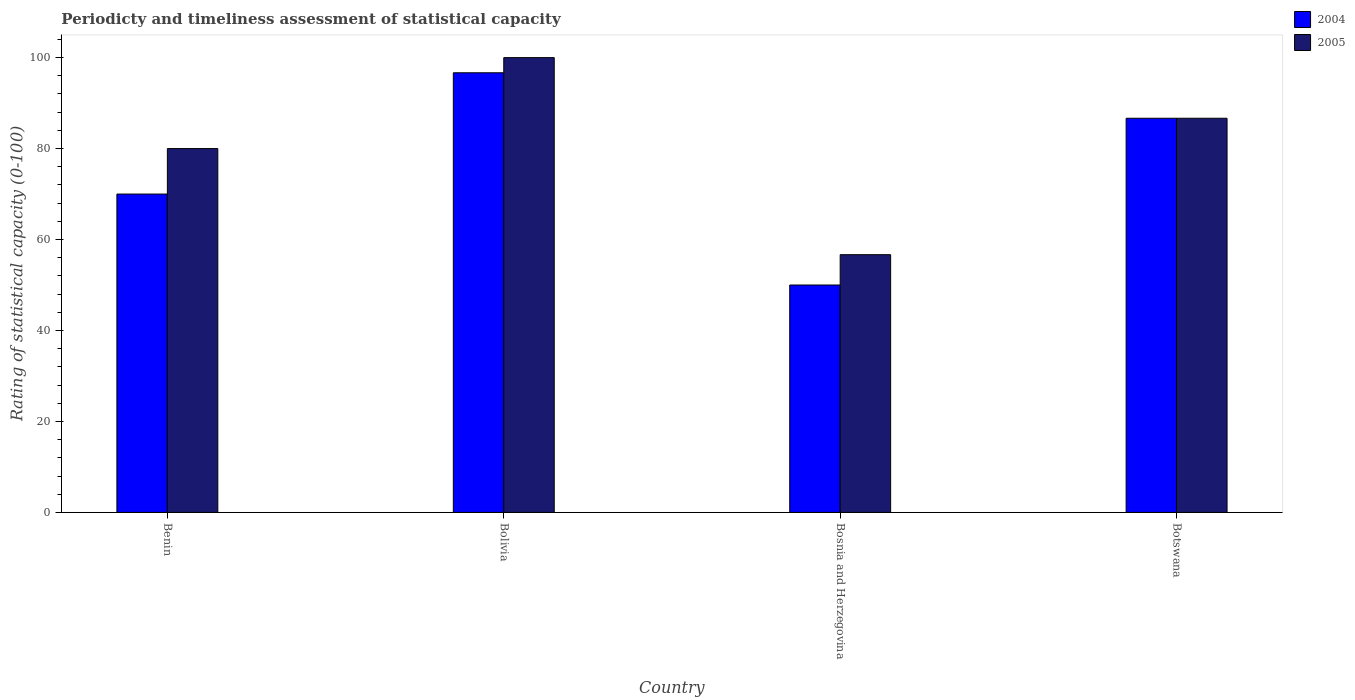How many different coloured bars are there?
Keep it short and to the point. 2. Are the number of bars per tick equal to the number of legend labels?
Provide a short and direct response. Yes. Are the number of bars on each tick of the X-axis equal?
Provide a short and direct response. Yes. What is the label of the 1st group of bars from the left?
Your response must be concise. Benin. In how many cases, is the number of bars for a given country not equal to the number of legend labels?
Your answer should be compact. 0. Across all countries, what is the maximum rating of statistical capacity in 2004?
Provide a succinct answer. 96.67. Across all countries, what is the minimum rating of statistical capacity in 2005?
Give a very brief answer. 56.67. In which country was the rating of statistical capacity in 2005 minimum?
Offer a terse response. Bosnia and Herzegovina. What is the total rating of statistical capacity in 2004 in the graph?
Offer a very short reply. 303.33. What is the difference between the rating of statistical capacity in 2005 in Bosnia and Herzegovina and that in Botswana?
Provide a short and direct response. -30. What is the difference between the rating of statistical capacity in 2004 in Bosnia and Herzegovina and the rating of statistical capacity in 2005 in Bolivia?
Your answer should be very brief. -50. What is the average rating of statistical capacity in 2004 per country?
Your answer should be compact. 75.83. What is the difference between the rating of statistical capacity of/in 2005 and rating of statistical capacity of/in 2004 in Botswana?
Your response must be concise. 0. In how many countries, is the rating of statistical capacity in 2005 greater than 68?
Give a very brief answer. 3. What is the ratio of the rating of statistical capacity in 2005 in Bolivia to that in Botswana?
Your answer should be very brief. 1.15. Is the rating of statistical capacity in 2005 in Benin less than that in Bosnia and Herzegovina?
Provide a short and direct response. No. Is the difference between the rating of statistical capacity in 2005 in Bolivia and Bosnia and Herzegovina greater than the difference between the rating of statistical capacity in 2004 in Bolivia and Bosnia and Herzegovina?
Offer a terse response. No. What is the difference between the highest and the second highest rating of statistical capacity in 2004?
Your response must be concise. 26.67. What is the difference between the highest and the lowest rating of statistical capacity in 2005?
Offer a very short reply. 43.33. In how many countries, is the rating of statistical capacity in 2004 greater than the average rating of statistical capacity in 2004 taken over all countries?
Offer a terse response. 2. What does the 1st bar from the left in Bolivia represents?
Provide a short and direct response. 2004. What does the 1st bar from the right in Bolivia represents?
Provide a short and direct response. 2005. Does the graph contain any zero values?
Your answer should be compact. No. Does the graph contain grids?
Offer a terse response. No. What is the title of the graph?
Your answer should be very brief. Periodicty and timeliness assessment of statistical capacity. What is the label or title of the X-axis?
Keep it short and to the point. Country. What is the label or title of the Y-axis?
Provide a short and direct response. Rating of statistical capacity (0-100). What is the Rating of statistical capacity (0-100) of 2004 in Bolivia?
Provide a succinct answer. 96.67. What is the Rating of statistical capacity (0-100) of 2004 in Bosnia and Herzegovina?
Give a very brief answer. 50. What is the Rating of statistical capacity (0-100) in 2005 in Bosnia and Herzegovina?
Ensure brevity in your answer.  56.67. What is the Rating of statistical capacity (0-100) of 2004 in Botswana?
Your answer should be very brief. 86.67. What is the Rating of statistical capacity (0-100) of 2005 in Botswana?
Your response must be concise. 86.67. Across all countries, what is the maximum Rating of statistical capacity (0-100) in 2004?
Ensure brevity in your answer.  96.67. Across all countries, what is the maximum Rating of statistical capacity (0-100) of 2005?
Your response must be concise. 100. Across all countries, what is the minimum Rating of statistical capacity (0-100) of 2004?
Your answer should be very brief. 50. Across all countries, what is the minimum Rating of statistical capacity (0-100) in 2005?
Offer a terse response. 56.67. What is the total Rating of statistical capacity (0-100) of 2004 in the graph?
Provide a short and direct response. 303.33. What is the total Rating of statistical capacity (0-100) in 2005 in the graph?
Your answer should be very brief. 323.33. What is the difference between the Rating of statistical capacity (0-100) in 2004 in Benin and that in Bolivia?
Offer a terse response. -26.67. What is the difference between the Rating of statistical capacity (0-100) in 2005 in Benin and that in Bolivia?
Ensure brevity in your answer.  -20. What is the difference between the Rating of statistical capacity (0-100) in 2005 in Benin and that in Bosnia and Herzegovina?
Your answer should be very brief. 23.33. What is the difference between the Rating of statistical capacity (0-100) of 2004 in Benin and that in Botswana?
Ensure brevity in your answer.  -16.67. What is the difference between the Rating of statistical capacity (0-100) in 2005 in Benin and that in Botswana?
Give a very brief answer. -6.67. What is the difference between the Rating of statistical capacity (0-100) in 2004 in Bolivia and that in Bosnia and Herzegovina?
Ensure brevity in your answer.  46.67. What is the difference between the Rating of statistical capacity (0-100) of 2005 in Bolivia and that in Bosnia and Herzegovina?
Provide a short and direct response. 43.33. What is the difference between the Rating of statistical capacity (0-100) of 2004 in Bolivia and that in Botswana?
Offer a very short reply. 10. What is the difference between the Rating of statistical capacity (0-100) in 2005 in Bolivia and that in Botswana?
Your response must be concise. 13.33. What is the difference between the Rating of statistical capacity (0-100) of 2004 in Bosnia and Herzegovina and that in Botswana?
Give a very brief answer. -36.67. What is the difference between the Rating of statistical capacity (0-100) in 2005 in Bosnia and Herzegovina and that in Botswana?
Provide a succinct answer. -30. What is the difference between the Rating of statistical capacity (0-100) in 2004 in Benin and the Rating of statistical capacity (0-100) in 2005 in Bolivia?
Make the answer very short. -30. What is the difference between the Rating of statistical capacity (0-100) of 2004 in Benin and the Rating of statistical capacity (0-100) of 2005 in Bosnia and Herzegovina?
Your response must be concise. 13.33. What is the difference between the Rating of statistical capacity (0-100) of 2004 in Benin and the Rating of statistical capacity (0-100) of 2005 in Botswana?
Provide a succinct answer. -16.67. What is the difference between the Rating of statistical capacity (0-100) in 2004 in Bolivia and the Rating of statistical capacity (0-100) in 2005 in Bosnia and Herzegovina?
Offer a very short reply. 40. What is the difference between the Rating of statistical capacity (0-100) of 2004 in Bolivia and the Rating of statistical capacity (0-100) of 2005 in Botswana?
Provide a succinct answer. 10. What is the difference between the Rating of statistical capacity (0-100) in 2004 in Bosnia and Herzegovina and the Rating of statistical capacity (0-100) in 2005 in Botswana?
Ensure brevity in your answer.  -36.67. What is the average Rating of statistical capacity (0-100) of 2004 per country?
Your response must be concise. 75.83. What is the average Rating of statistical capacity (0-100) of 2005 per country?
Provide a short and direct response. 80.83. What is the difference between the Rating of statistical capacity (0-100) in 2004 and Rating of statistical capacity (0-100) in 2005 in Bolivia?
Ensure brevity in your answer.  -3.33. What is the difference between the Rating of statistical capacity (0-100) of 2004 and Rating of statistical capacity (0-100) of 2005 in Bosnia and Herzegovina?
Ensure brevity in your answer.  -6.67. What is the difference between the Rating of statistical capacity (0-100) in 2004 and Rating of statistical capacity (0-100) in 2005 in Botswana?
Your response must be concise. 0. What is the ratio of the Rating of statistical capacity (0-100) in 2004 in Benin to that in Bolivia?
Provide a short and direct response. 0.72. What is the ratio of the Rating of statistical capacity (0-100) in 2004 in Benin to that in Bosnia and Herzegovina?
Give a very brief answer. 1.4. What is the ratio of the Rating of statistical capacity (0-100) of 2005 in Benin to that in Bosnia and Herzegovina?
Your answer should be very brief. 1.41. What is the ratio of the Rating of statistical capacity (0-100) of 2004 in Benin to that in Botswana?
Offer a terse response. 0.81. What is the ratio of the Rating of statistical capacity (0-100) in 2005 in Benin to that in Botswana?
Provide a succinct answer. 0.92. What is the ratio of the Rating of statistical capacity (0-100) in 2004 in Bolivia to that in Bosnia and Herzegovina?
Provide a short and direct response. 1.93. What is the ratio of the Rating of statistical capacity (0-100) of 2005 in Bolivia to that in Bosnia and Herzegovina?
Give a very brief answer. 1.76. What is the ratio of the Rating of statistical capacity (0-100) in 2004 in Bolivia to that in Botswana?
Provide a succinct answer. 1.12. What is the ratio of the Rating of statistical capacity (0-100) of 2005 in Bolivia to that in Botswana?
Your answer should be very brief. 1.15. What is the ratio of the Rating of statistical capacity (0-100) of 2004 in Bosnia and Herzegovina to that in Botswana?
Provide a succinct answer. 0.58. What is the ratio of the Rating of statistical capacity (0-100) of 2005 in Bosnia and Herzegovina to that in Botswana?
Make the answer very short. 0.65. What is the difference between the highest and the second highest Rating of statistical capacity (0-100) in 2004?
Your answer should be very brief. 10. What is the difference between the highest and the second highest Rating of statistical capacity (0-100) in 2005?
Your answer should be very brief. 13.33. What is the difference between the highest and the lowest Rating of statistical capacity (0-100) in 2004?
Keep it short and to the point. 46.67. What is the difference between the highest and the lowest Rating of statistical capacity (0-100) of 2005?
Your answer should be compact. 43.33. 